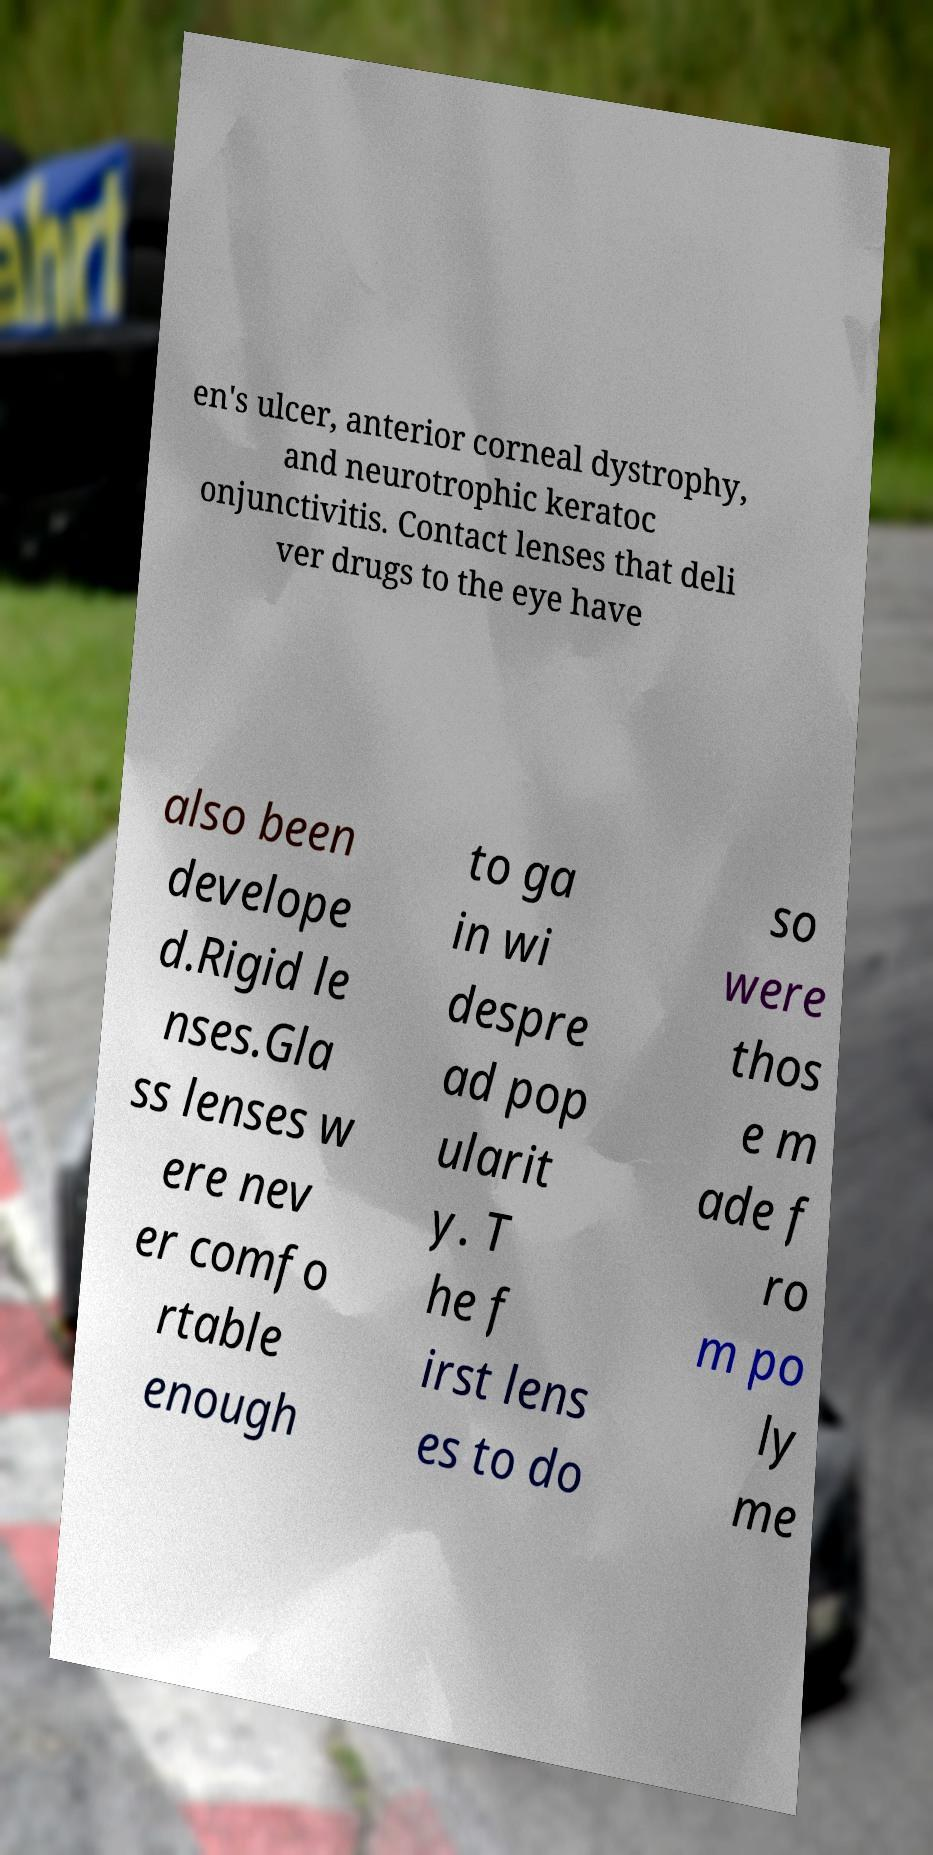What messages or text are displayed in this image? I need them in a readable, typed format. en's ulcer, anterior corneal dystrophy, and neurotrophic keratoc onjunctivitis. Contact lenses that deli ver drugs to the eye have also been develope d.Rigid le nses.Gla ss lenses w ere nev er comfo rtable enough to ga in wi despre ad pop ularit y. T he f irst lens es to do so were thos e m ade f ro m po ly me 